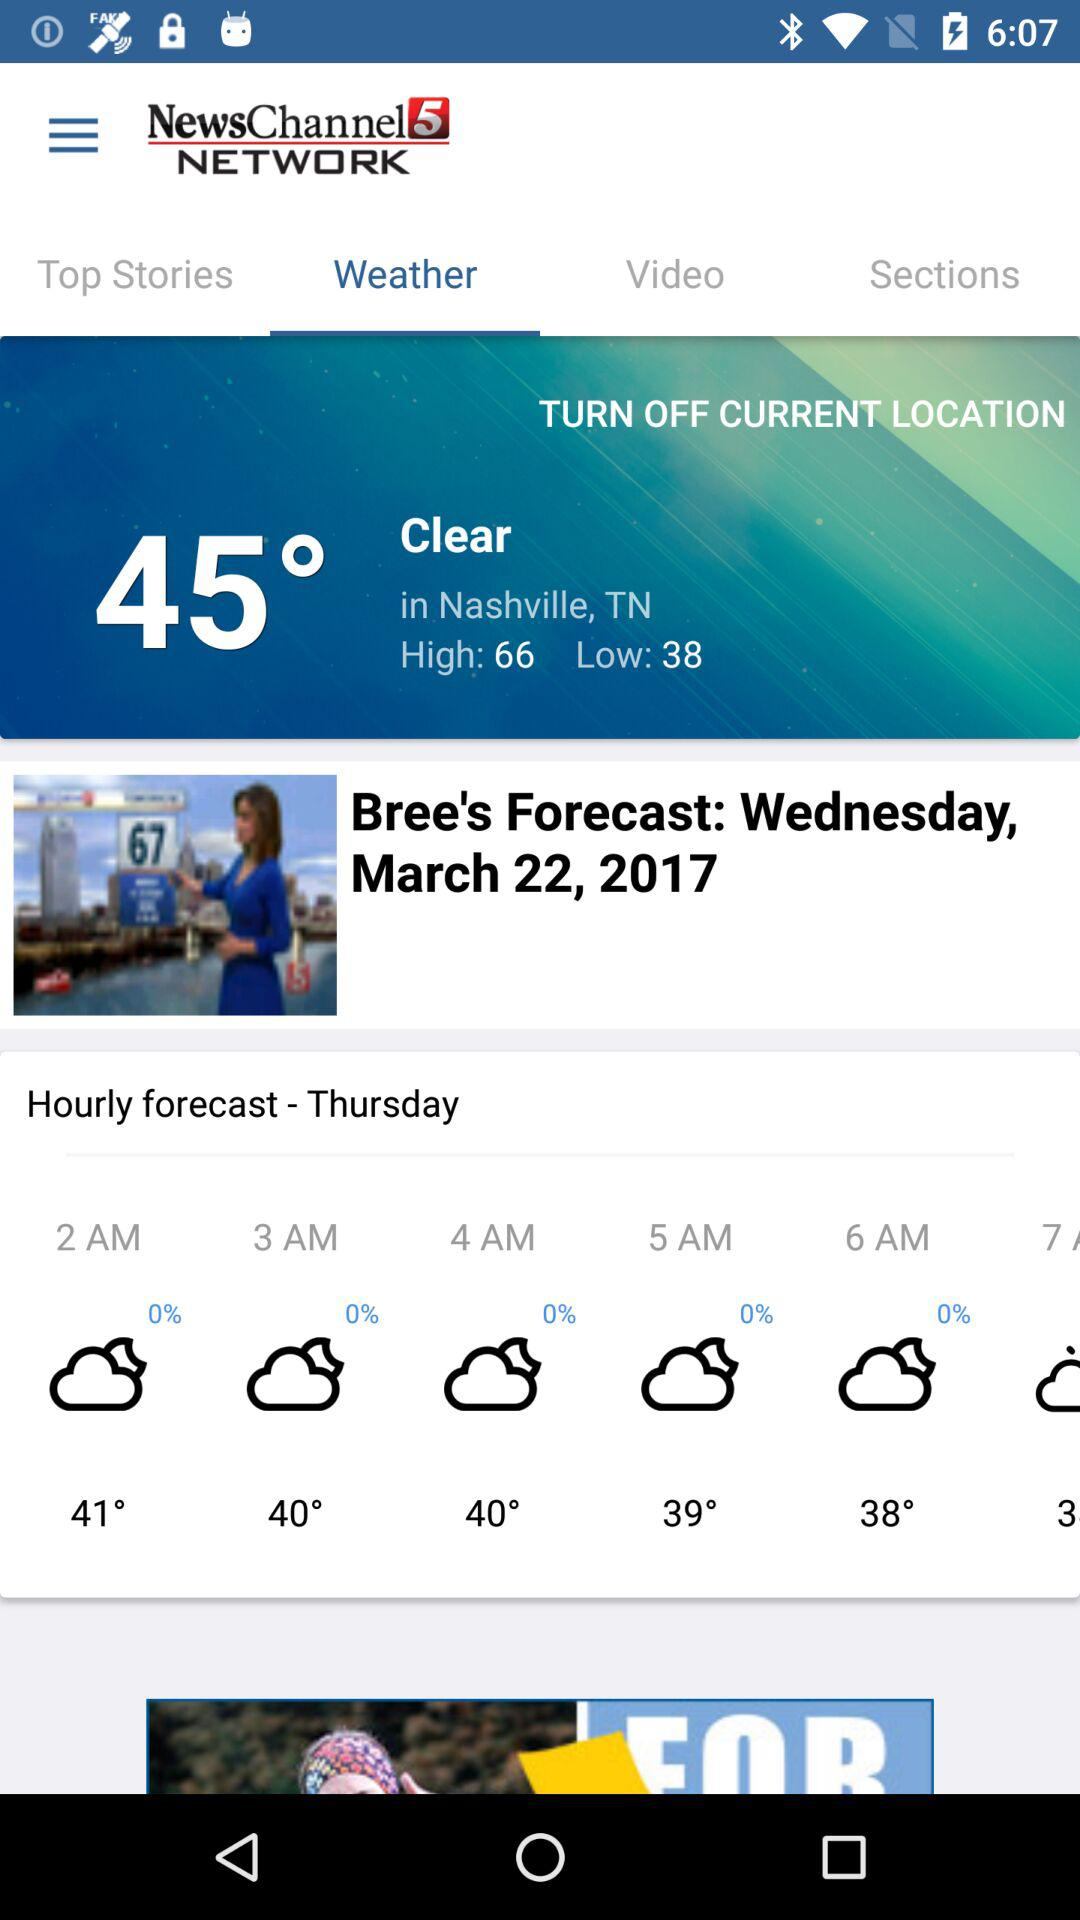What is the hourly forecast update? The hourly forecast updates are 41° at 2 AM, 40° at 3 AM, 40° at 4 AM, 39° at 5 AM and 38° at 6 AM. 